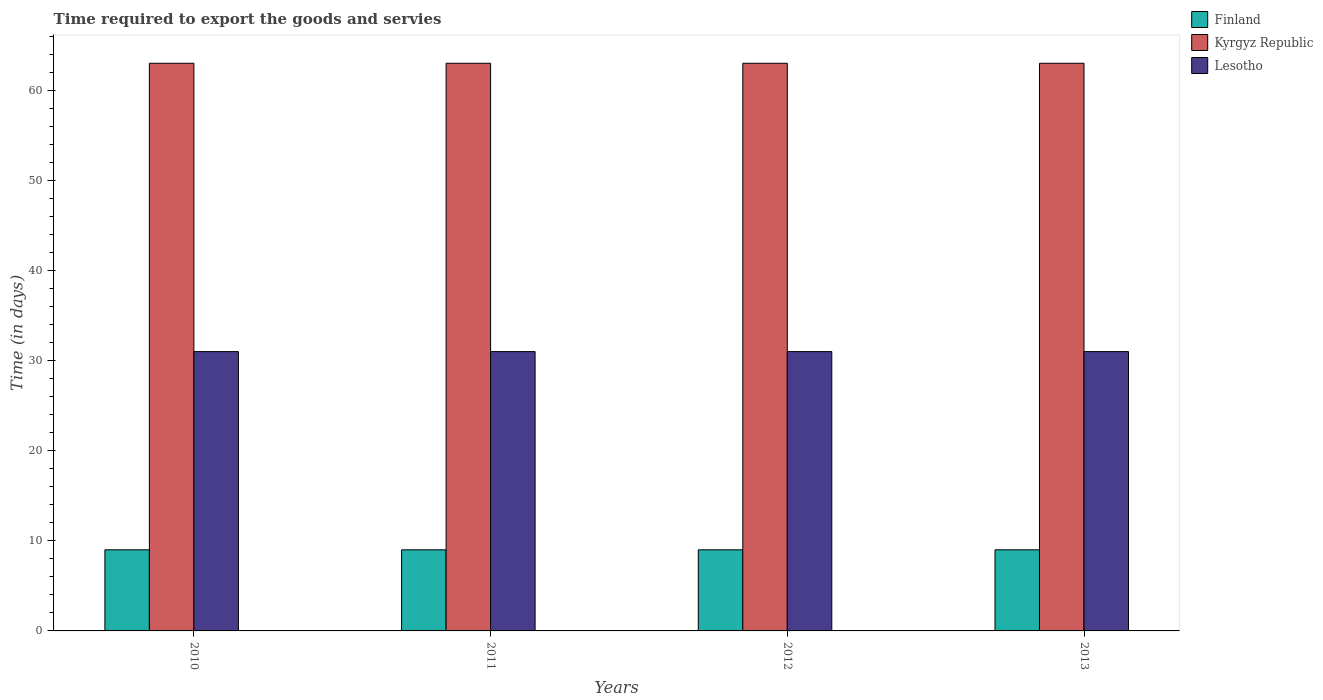How many different coloured bars are there?
Provide a succinct answer. 3. Are the number of bars on each tick of the X-axis equal?
Your answer should be very brief. Yes. How many bars are there on the 1st tick from the right?
Make the answer very short. 3. What is the label of the 4th group of bars from the left?
Provide a short and direct response. 2013. What is the number of days required to export the goods and services in Lesotho in 2013?
Ensure brevity in your answer.  31. Across all years, what is the maximum number of days required to export the goods and services in Finland?
Your answer should be compact. 9. Across all years, what is the minimum number of days required to export the goods and services in Finland?
Your answer should be very brief. 9. In which year was the number of days required to export the goods and services in Finland maximum?
Keep it short and to the point. 2010. In which year was the number of days required to export the goods and services in Kyrgyz Republic minimum?
Offer a terse response. 2010. What is the total number of days required to export the goods and services in Kyrgyz Republic in the graph?
Provide a short and direct response. 252. What is the difference between the number of days required to export the goods and services in Kyrgyz Republic in 2010 and that in 2013?
Your answer should be very brief. 0. What is the difference between the number of days required to export the goods and services in Finland in 2011 and the number of days required to export the goods and services in Kyrgyz Republic in 2010?
Keep it short and to the point. -54. In the year 2011, what is the difference between the number of days required to export the goods and services in Lesotho and number of days required to export the goods and services in Kyrgyz Republic?
Offer a terse response. -32. In how many years, is the number of days required to export the goods and services in Lesotho greater than 42 days?
Make the answer very short. 0. What is the ratio of the number of days required to export the goods and services in Lesotho in 2011 to that in 2012?
Provide a short and direct response. 1. Is the number of days required to export the goods and services in Finland in 2011 less than that in 2012?
Give a very brief answer. No. In how many years, is the number of days required to export the goods and services in Lesotho greater than the average number of days required to export the goods and services in Lesotho taken over all years?
Provide a succinct answer. 0. Is the sum of the number of days required to export the goods and services in Lesotho in 2011 and 2013 greater than the maximum number of days required to export the goods and services in Finland across all years?
Make the answer very short. Yes. What does the 2nd bar from the left in 2011 represents?
Give a very brief answer. Kyrgyz Republic. How many years are there in the graph?
Offer a terse response. 4. What is the difference between two consecutive major ticks on the Y-axis?
Your answer should be very brief. 10. Are the values on the major ticks of Y-axis written in scientific E-notation?
Provide a succinct answer. No. Where does the legend appear in the graph?
Offer a terse response. Top right. How are the legend labels stacked?
Offer a very short reply. Vertical. What is the title of the graph?
Provide a short and direct response. Time required to export the goods and servies. Does "Japan" appear as one of the legend labels in the graph?
Your response must be concise. No. What is the label or title of the X-axis?
Offer a terse response. Years. What is the label or title of the Y-axis?
Your response must be concise. Time (in days). What is the Time (in days) in Lesotho in 2010?
Offer a very short reply. 31. What is the Time (in days) of Lesotho in 2011?
Offer a terse response. 31. What is the Time (in days) of Finland in 2012?
Your answer should be compact. 9. What is the Time (in days) in Kyrgyz Republic in 2012?
Make the answer very short. 63. What is the Time (in days) of Lesotho in 2012?
Provide a short and direct response. 31. What is the Time (in days) in Finland in 2013?
Make the answer very short. 9. Across all years, what is the maximum Time (in days) of Lesotho?
Make the answer very short. 31. Across all years, what is the minimum Time (in days) of Finland?
Your answer should be compact. 9. Across all years, what is the minimum Time (in days) in Lesotho?
Provide a succinct answer. 31. What is the total Time (in days) in Finland in the graph?
Ensure brevity in your answer.  36. What is the total Time (in days) in Kyrgyz Republic in the graph?
Provide a short and direct response. 252. What is the total Time (in days) in Lesotho in the graph?
Make the answer very short. 124. What is the difference between the Time (in days) in Lesotho in 2010 and that in 2011?
Offer a very short reply. 0. What is the difference between the Time (in days) in Finland in 2010 and that in 2012?
Provide a short and direct response. 0. What is the difference between the Time (in days) in Lesotho in 2010 and that in 2012?
Provide a short and direct response. 0. What is the difference between the Time (in days) of Finland in 2011 and that in 2012?
Provide a succinct answer. 0. What is the difference between the Time (in days) of Lesotho in 2011 and that in 2012?
Provide a short and direct response. 0. What is the difference between the Time (in days) in Finland in 2011 and that in 2013?
Offer a terse response. 0. What is the difference between the Time (in days) in Kyrgyz Republic in 2011 and that in 2013?
Offer a very short reply. 0. What is the difference between the Time (in days) of Kyrgyz Republic in 2012 and that in 2013?
Your answer should be compact. 0. What is the difference between the Time (in days) of Finland in 2010 and the Time (in days) of Kyrgyz Republic in 2011?
Offer a terse response. -54. What is the difference between the Time (in days) of Finland in 2010 and the Time (in days) of Lesotho in 2011?
Provide a succinct answer. -22. What is the difference between the Time (in days) of Kyrgyz Republic in 2010 and the Time (in days) of Lesotho in 2011?
Provide a short and direct response. 32. What is the difference between the Time (in days) of Finland in 2010 and the Time (in days) of Kyrgyz Republic in 2012?
Your response must be concise. -54. What is the difference between the Time (in days) of Kyrgyz Republic in 2010 and the Time (in days) of Lesotho in 2012?
Provide a succinct answer. 32. What is the difference between the Time (in days) in Finland in 2010 and the Time (in days) in Kyrgyz Republic in 2013?
Give a very brief answer. -54. What is the difference between the Time (in days) of Finland in 2010 and the Time (in days) of Lesotho in 2013?
Ensure brevity in your answer.  -22. What is the difference between the Time (in days) in Finland in 2011 and the Time (in days) in Kyrgyz Republic in 2012?
Provide a short and direct response. -54. What is the difference between the Time (in days) in Kyrgyz Republic in 2011 and the Time (in days) in Lesotho in 2012?
Make the answer very short. 32. What is the difference between the Time (in days) in Finland in 2011 and the Time (in days) in Kyrgyz Republic in 2013?
Keep it short and to the point. -54. What is the difference between the Time (in days) in Kyrgyz Republic in 2011 and the Time (in days) in Lesotho in 2013?
Your answer should be very brief. 32. What is the difference between the Time (in days) in Finland in 2012 and the Time (in days) in Kyrgyz Republic in 2013?
Offer a terse response. -54. What is the difference between the Time (in days) of Kyrgyz Republic in 2012 and the Time (in days) of Lesotho in 2013?
Provide a short and direct response. 32. What is the average Time (in days) of Finland per year?
Your answer should be compact. 9. In the year 2010, what is the difference between the Time (in days) of Finland and Time (in days) of Kyrgyz Republic?
Ensure brevity in your answer.  -54. In the year 2010, what is the difference between the Time (in days) of Kyrgyz Republic and Time (in days) of Lesotho?
Make the answer very short. 32. In the year 2011, what is the difference between the Time (in days) in Finland and Time (in days) in Kyrgyz Republic?
Your answer should be compact. -54. In the year 2012, what is the difference between the Time (in days) in Finland and Time (in days) in Kyrgyz Republic?
Keep it short and to the point. -54. In the year 2012, what is the difference between the Time (in days) of Finland and Time (in days) of Lesotho?
Give a very brief answer. -22. In the year 2012, what is the difference between the Time (in days) of Kyrgyz Republic and Time (in days) of Lesotho?
Ensure brevity in your answer.  32. In the year 2013, what is the difference between the Time (in days) in Finland and Time (in days) in Kyrgyz Republic?
Provide a succinct answer. -54. What is the ratio of the Time (in days) of Kyrgyz Republic in 2010 to that in 2011?
Offer a terse response. 1. What is the ratio of the Time (in days) in Finland in 2010 to that in 2012?
Your response must be concise. 1. What is the ratio of the Time (in days) in Kyrgyz Republic in 2010 to that in 2012?
Offer a terse response. 1. What is the ratio of the Time (in days) of Lesotho in 2010 to that in 2012?
Your answer should be very brief. 1. What is the ratio of the Time (in days) in Kyrgyz Republic in 2010 to that in 2013?
Your answer should be compact. 1. What is the ratio of the Time (in days) in Finland in 2011 to that in 2012?
Keep it short and to the point. 1. What is the ratio of the Time (in days) in Kyrgyz Republic in 2011 to that in 2012?
Make the answer very short. 1. What is the ratio of the Time (in days) of Finland in 2011 to that in 2013?
Your answer should be compact. 1. What is the ratio of the Time (in days) of Lesotho in 2011 to that in 2013?
Offer a terse response. 1. What is the ratio of the Time (in days) in Finland in 2012 to that in 2013?
Give a very brief answer. 1. What is the difference between the highest and the second highest Time (in days) of Kyrgyz Republic?
Keep it short and to the point. 0. What is the difference between the highest and the lowest Time (in days) of Kyrgyz Republic?
Your answer should be compact. 0. What is the difference between the highest and the lowest Time (in days) of Lesotho?
Make the answer very short. 0. 